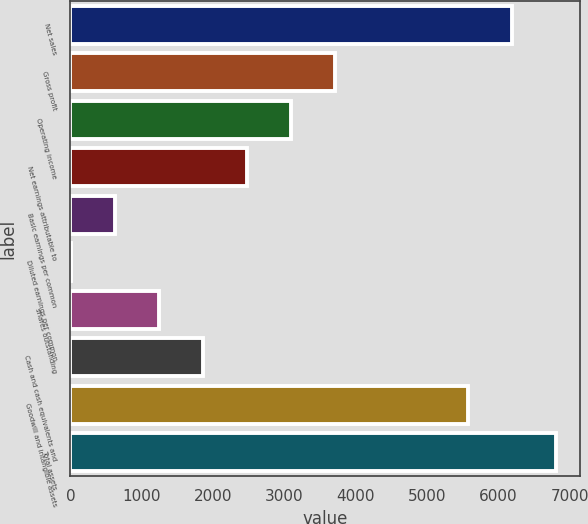Convert chart to OTSL. <chart><loc_0><loc_0><loc_500><loc_500><bar_chart><fcel>Net sales<fcel>Gross profit<fcel>Operating income<fcel>Net earnings attributable to<fcel>Basic earnings per common<fcel>Diluted earnings per common<fcel>shares outstanding<fcel>Cash and cash equivalents and<fcel>Goodwill and intangible assets<fcel>Total assets<nl><fcel>6187.79<fcel>3714.79<fcel>3096.54<fcel>2478.29<fcel>623.54<fcel>5.29<fcel>1241.79<fcel>1860.04<fcel>5569.54<fcel>6806.04<nl></chart> 